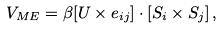Convert formula to latex. <formula><loc_0><loc_0><loc_500><loc_500>V _ { M E } = \beta [ { U } \times { e } _ { i j } ] \cdot \left [ { S } _ { i } \times { S } _ { j } \right ] ,</formula> 